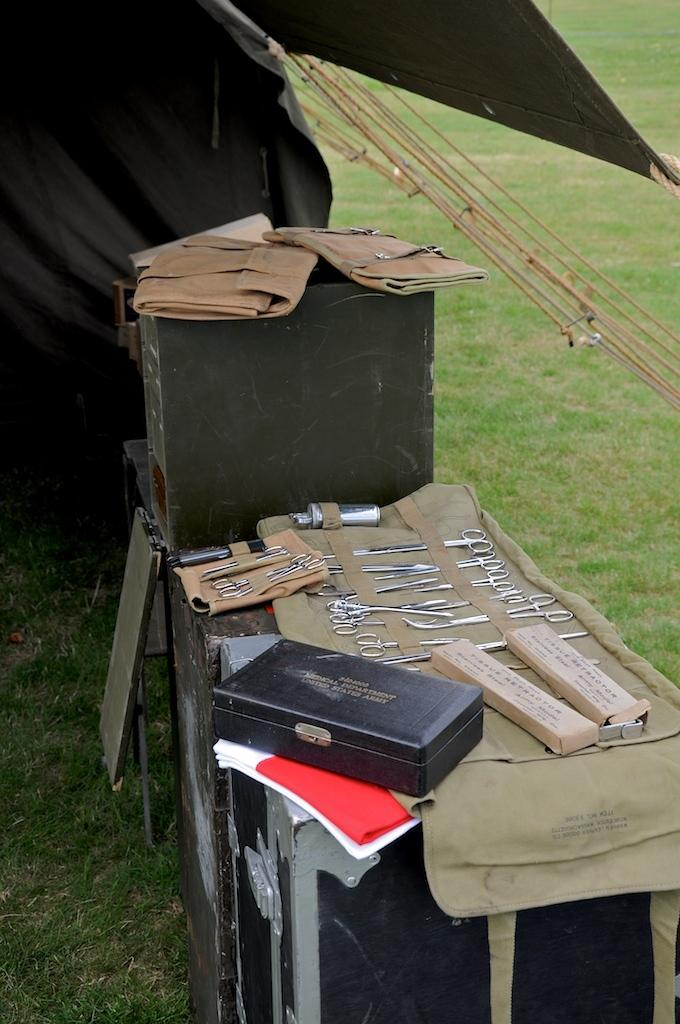What is the main object in the image? There is a box in the image. What is on the box? There are tools and other things on the box. Can you describe the tools on the box? Unfortunately, the facts provided do not give specific details about the tools. What is visible behind the tools on the box? There are ropes behind the tools. What type of environment is visible in the image? There is grass visible in the image, suggesting an outdoor setting. How many chickens are visible in the image? There are no chickens present in the image. What is the distance between the box and the garden in the image? There is no garden mentioned in the facts provided, so it is impossible to determine the distance between the box and a garden. 